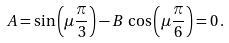Convert formula to latex. <formula><loc_0><loc_0><loc_500><loc_500>A = \sin \left ( \mu \frac { \pi } { 3 } \right ) - B \, \cos \left ( \mu \frac { \pi } { 6 } \right ) = 0 \, .</formula> 